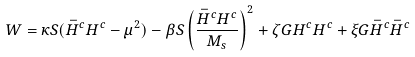Convert formula to latex. <formula><loc_0><loc_0><loc_500><loc_500>W = \kappa S ( \bar { H } ^ { c } H ^ { c } - \mu ^ { 2 } ) - \beta S \left ( \frac { \bar { H } ^ { c } H ^ { c } } { M _ { s } } \right ) ^ { 2 } + \zeta G H ^ { c } H ^ { c } + \xi G \bar { H } ^ { c } \bar { H } ^ { c }</formula> 